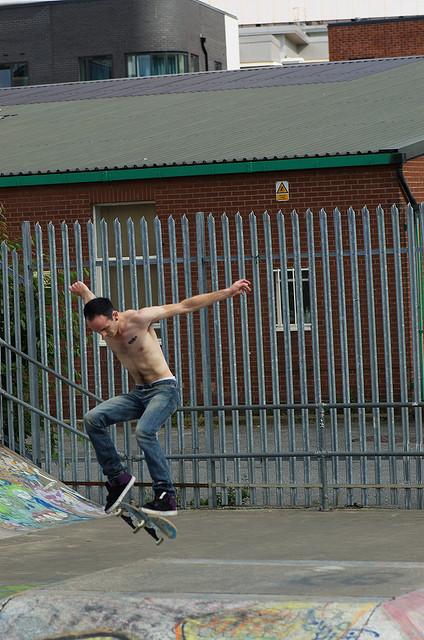Why isn't the man wearing a shirt?
Write a very short answer. Hot. Is there a fence?
Concise answer only. Yes. What is under the man's feet?
Give a very brief answer. Skateboard. 